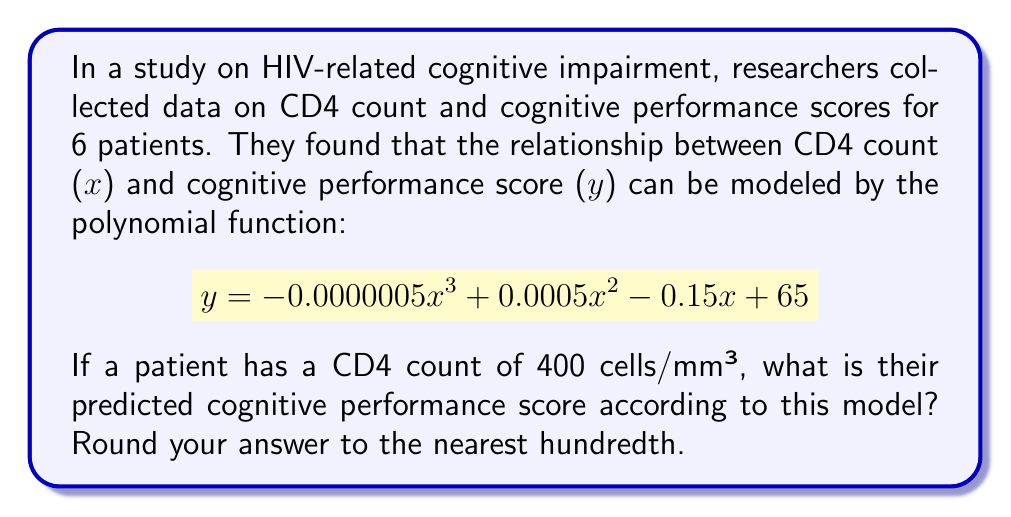Help me with this question. To solve this problem, we need to substitute the given CD4 count (x = 400) into the polynomial function and calculate the result. Let's break it down step by step:

1) The given polynomial function is:
   $$ y = -0.0000005x^3 + 0.0005x^2 - 0.15x + 65 $$

2) Substitute x = 400:
   $$ y = -0.0000005(400)^3 + 0.0005(400)^2 - 0.15(400) + 65 $$

3) Calculate each term:
   a) $-0.0000005(400)^3 = -0.0000005 \times 64,000,000 = -32$
   b) $0.0005(400)^2 = 0.0005 \times 160,000 = 80$
   c) $-0.15(400) = -60$
   d) The constant term is already 65

4) Sum up all the terms:
   $$ y = -32 + 80 - 60 + 65 = 53 $$

5) Round to the nearest hundredth:
   $$ y \approx 53.00 $$

Therefore, the predicted cognitive performance score for a patient with a CD4 count of 400 cells/mm³ is 53.00.
Answer: 53.00 